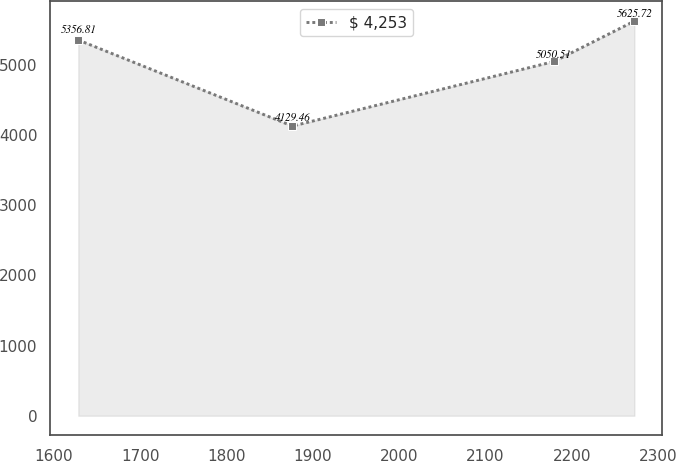Convert chart to OTSL. <chart><loc_0><loc_0><loc_500><loc_500><line_chart><ecel><fcel>$ 4,253<nl><fcel>1628.12<fcel>5356.81<nl><fcel>1876.3<fcel>4129.46<nl><fcel>2179.69<fcel>5050.51<nl><fcel>2272.74<fcel>5625.72<nl></chart> 